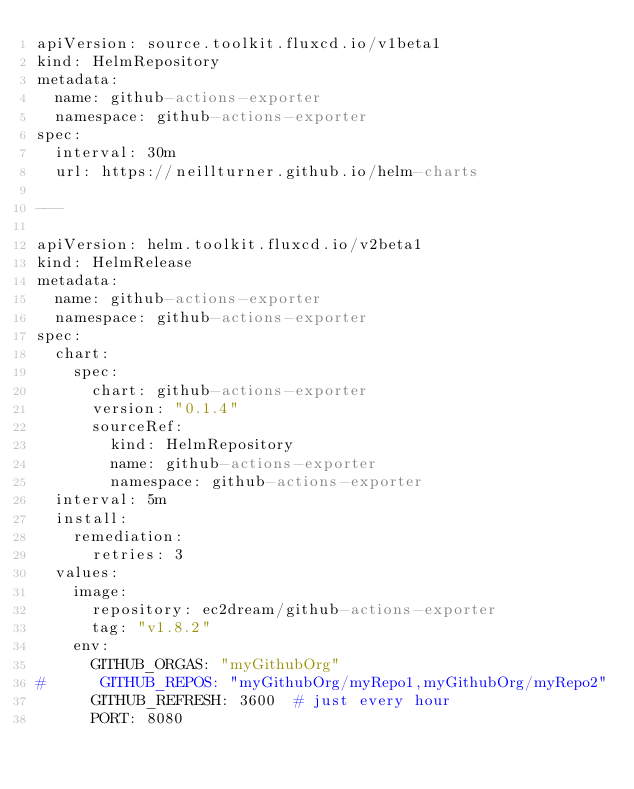<code> <loc_0><loc_0><loc_500><loc_500><_YAML_>apiVersion: source.toolkit.fluxcd.io/v1beta1
kind: HelmRepository
metadata:
  name: github-actions-exporter
  namespace: github-actions-exporter
spec:
  interval: 30m
  url: https://neillturner.github.io/helm-charts

---

apiVersion: helm.toolkit.fluxcd.io/v2beta1
kind: HelmRelease
metadata:
  name: github-actions-exporter
  namespace: github-actions-exporter
spec:
  chart:
    spec:
      chart: github-actions-exporter
      version: "0.1.4"
      sourceRef:
        kind: HelmRepository
        name: github-actions-exporter
        namespace: github-actions-exporter
  interval: 5m
  install:
    remediation:
      retries: 3
  values:
    image:    
      repository: ec2dream/github-actions-exporter
      tag: "v1.8.2"
    env:
      GITHUB_ORGAS: "myGithubOrg"
#      GITHUB_REPOS: "myGithubOrg/myRepo1,myGithubOrg/myRepo2"
      GITHUB_REFRESH: 3600  # just every hour
      PORT: 8080

</code> 